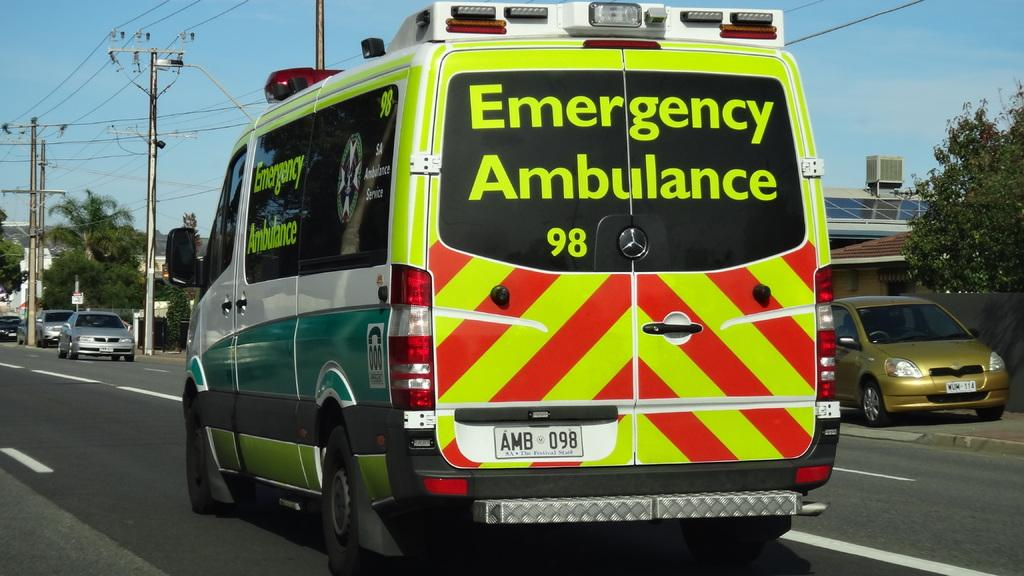What can be seen on the road in the image? Vehicles are on the road in the image. What type of natural elements are visible in the background? There are trees in the background. What type of energy source is present in the background? A solar panel is present in the background. What type of infrastructure is visible in the background? Current poles with cables are visible in the background. What type of building is visible in the background? There is a house in the background. What is the color of the sky in the image? The sky is blue in the image. What type of juice is being served at the destruction scene in the image? There is no destruction scene or juice present in the image. Is there a crook visible in the image? There is no crook present in the image. 